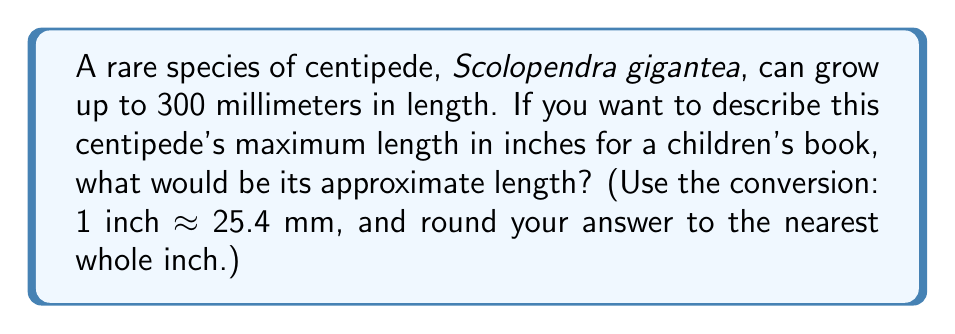Can you solve this math problem? Let's solve this step-by-step:

1) We know that 1 inch ≈ 25.4 mm
   This means that to convert from mm to inches, we need to divide by 25.4

2) Set up the conversion:
   $$ \text{Length in inches} = \frac{\text{Length in mm}}{25.4 \text{ mm/inch}} $$

3) Plug in the known length:
   $$ \text{Length in inches} = \frac{300 \text{ mm}}{25.4 \text{ mm/inch}} $$

4) Perform the division:
   $$ \text{Length in inches} = 11.81102362204724... $$

5) Round to the nearest whole inch:
   11.81 rounds up to 12

Therefore, the Scolopendra gigantea centipede would be approximately 12 inches long.
Answer: 12 inches 